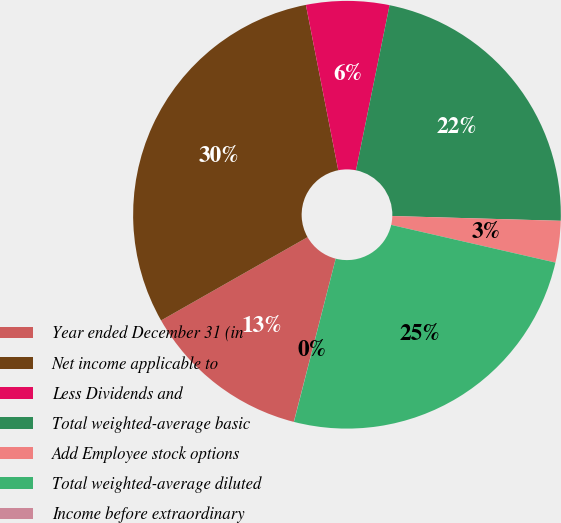Convert chart. <chart><loc_0><loc_0><loc_500><loc_500><pie_chart><fcel>Year ended December 31 (in<fcel>Net income applicable to<fcel>Less Dividends and<fcel>Total weighted-average basic<fcel>Add Employee stock options<fcel>Total weighted-average diluted<fcel>Income before extraordinary<nl><fcel>12.77%<fcel>30.15%<fcel>6.27%<fcel>22.26%<fcel>3.14%<fcel>25.4%<fcel>0.01%<nl></chart> 